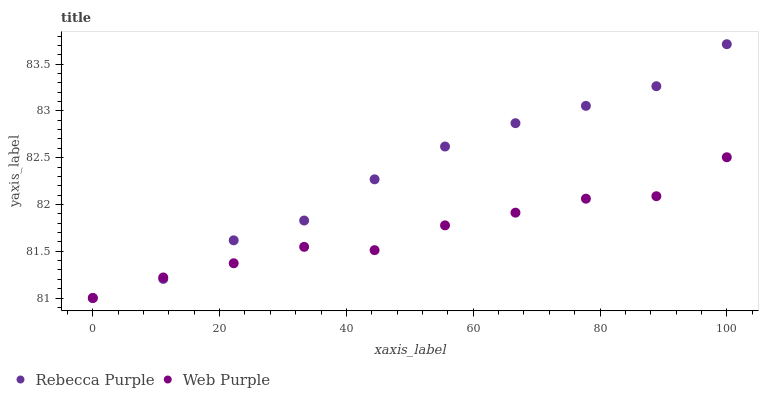Does Web Purple have the minimum area under the curve?
Answer yes or no. Yes. Does Rebecca Purple have the maximum area under the curve?
Answer yes or no. Yes. Does Rebecca Purple have the minimum area under the curve?
Answer yes or no. No. Is Rebecca Purple the smoothest?
Answer yes or no. Yes. Is Web Purple the roughest?
Answer yes or no. Yes. Is Rebecca Purple the roughest?
Answer yes or no. No. Does Web Purple have the lowest value?
Answer yes or no. Yes. Does Rebecca Purple have the lowest value?
Answer yes or no. No. Does Rebecca Purple have the highest value?
Answer yes or no. Yes. Does Web Purple intersect Rebecca Purple?
Answer yes or no. Yes. Is Web Purple less than Rebecca Purple?
Answer yes or no. No. Is Web Purple greater than Rebecca Purple?
Answer yes or no. No. 